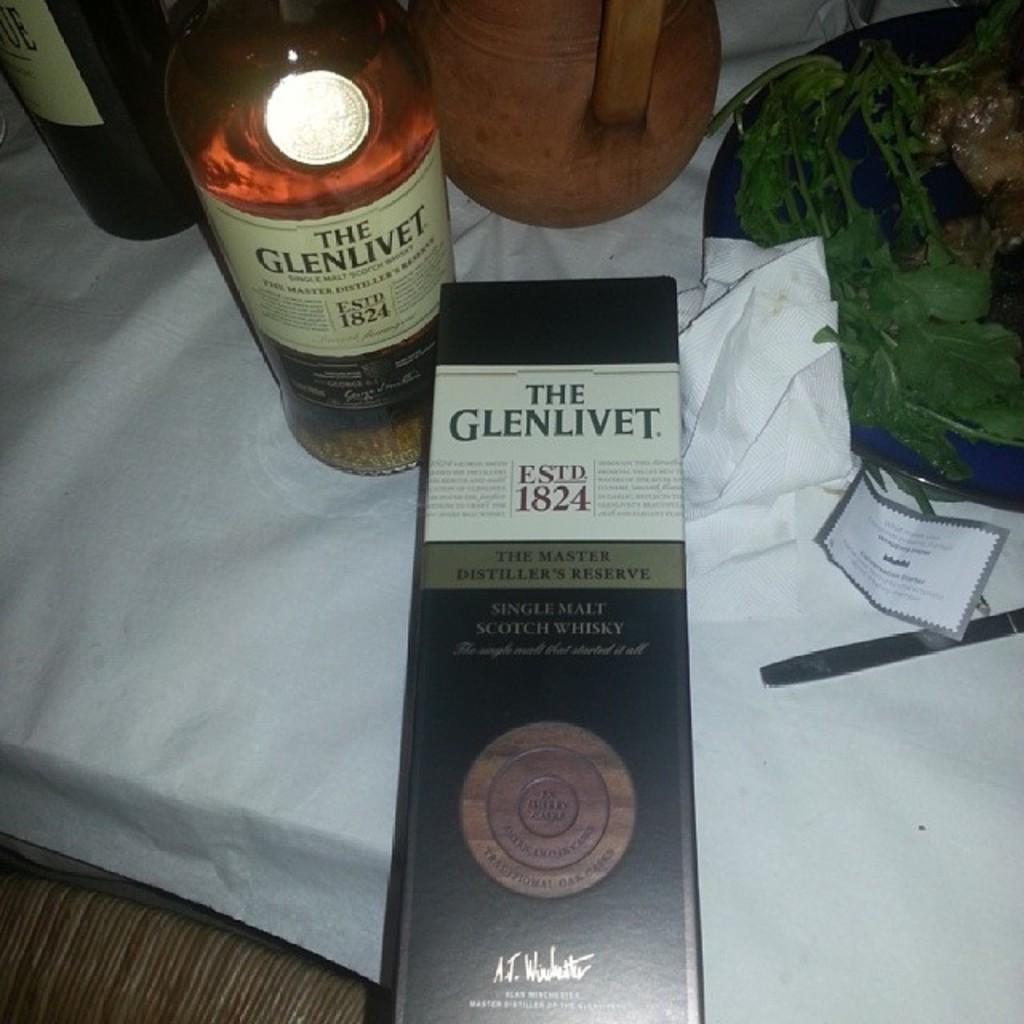<image>
Provide a brief description of the given image. A bottle of Glenlivit sits on a table covered by a white cloth. 